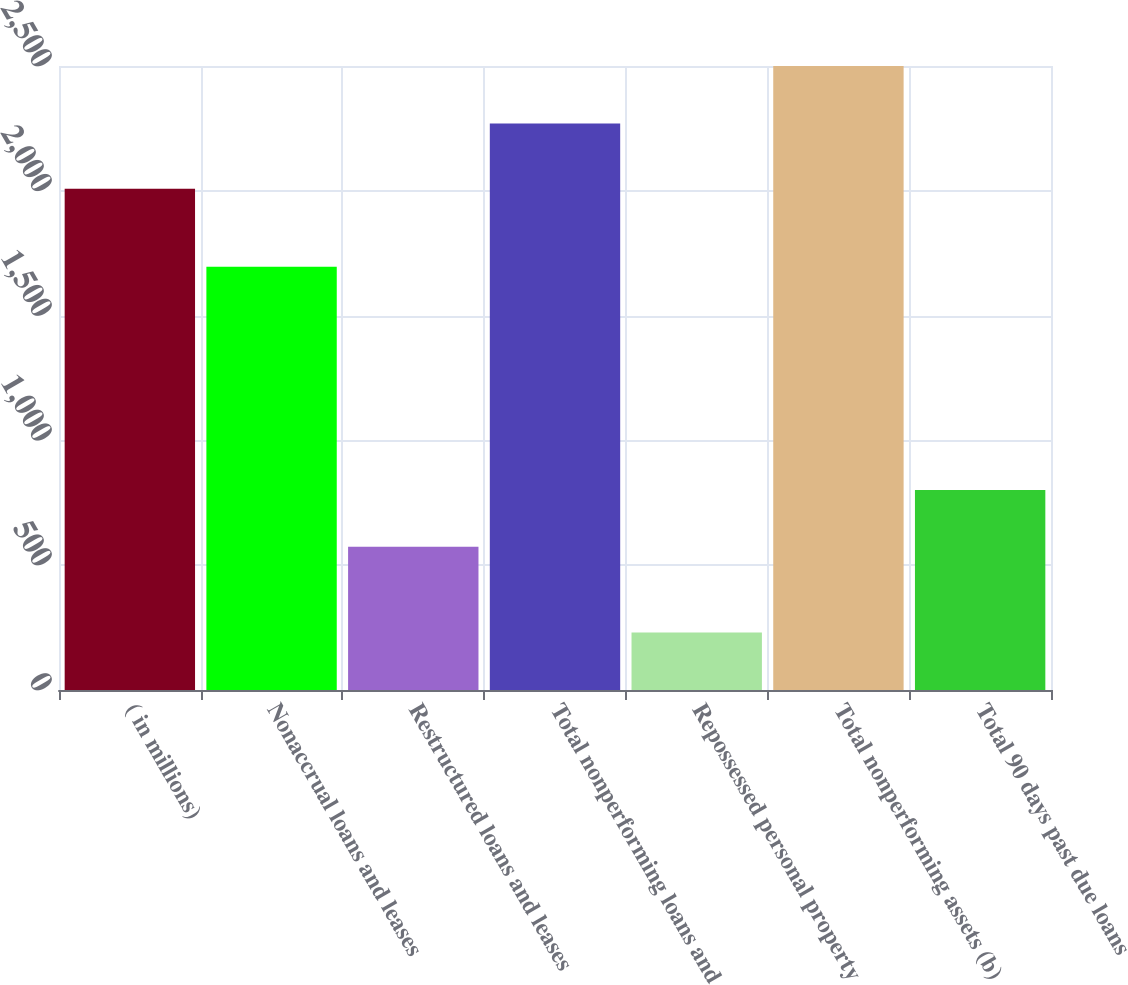Convert chart to OTSL. <chart><loc_0><loc_0><loc_500><loc_500><bar_chart><fcel>( in millions)<fcel>Nonaccrual loans and leases<fcel>Restructured loans and leases<fcel>Total nonperforming loans and<fcel>Repossessed personal property<fcel>Total nonperforming assets (b)<fcel>Total 90 days past due loans<nl><fcel>2008<fcel>1696<fcel>574<fcel>2270<fcel>230<fcel>2500<fcel>801<nl></chart> 